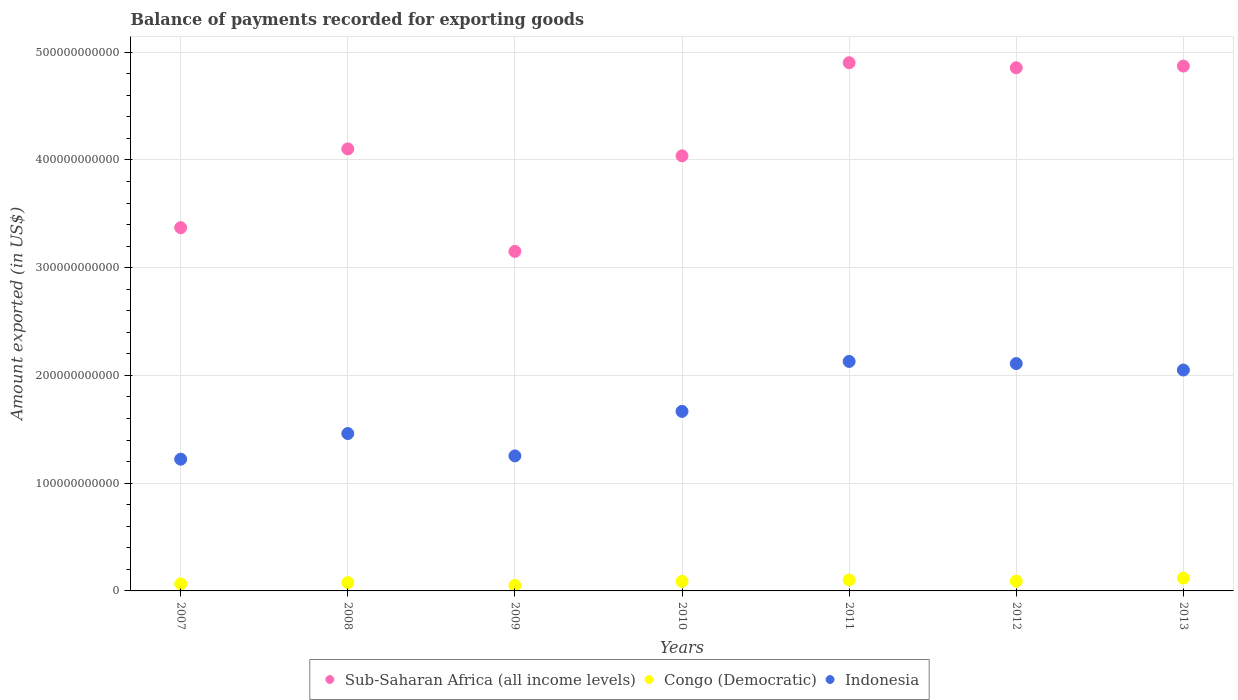How many different coloured dotlines are there?
Ensure brevity in your answer.  3. Is the number of dotlines equal to the number of legend labels?
Keep it short and to the point. Yes. What is the amount exported in Congo (Democratic) in 2011?
Give a very brief answer. 1.02e+1. Across all years, what is the maximum amount exported in Congo (Democratic)?
Your answer should be compact. 1.19e+1. Across all years, what is the minimum amount exported in Indonesia?
Keep it short and to the point. 1.22e+11. In which year was the amount exported in Congo (Democratic) maximum?
Your answer should be very brief. 2013. What is the total amount exported in Indonesia in the graph?
Keep it short and to the point. 1.19e+12. What is the difference between the amount exported in Congo (Democratic) in 2008 and that in 2010?
Offer a terse response. -1.17e+09. What is the difference between the amount exported in Congo (Democratic) in 2013 and the amount exported in Indonesia in 2010?
Offer a very short reply. -1.55e+11. What is the average amount exported in Indonesia per year?
Provide a succinct answer. 1.70e+11. In the year 2012, what is the difference between the amount exported in Congo (Democratic) and amount exported in Indonesia?
Give a very brief answer. -2.02e+11. In how many years, is the amount exported in Sub-Saharan Africa (all income levels) greater than 160000000000 US$?
Your response must be concise. 7. What is the ratio of the amount exported in Sub-Saharan Africa (all income levels) in 2007 to that in 2008?
Keep it short and to the point. 0.82. Is the amount exported in Sub-Saharan Africa (all income levels) in 2008 less than that in 2011?
Offer a terse response. Yes. Is the difference between the amount exported in Congo (Democratic) in 2008 and 2010 greater than the difference between the amount exported in Indonesia in 2008 and 2010?
Your answer should be compact. Yes. What is the difference between the highest and the second highest amount exported in Sub-Saharan Africa (all income levels)?
Ensure brevity in your answer.  3.12e+09. What is the difference between the highest and the lowest amount exported in Congo (Democratic)?
Keep it short and to the point. 6.89e+09. In how many years, is the amount exported in Indonesia greater than the average amount exported in Indonesia taken over all years?
Provide a short and direct response. 3. Is the sum of the amount exported in Indonesia in 2007 and 2012 greater than the maximum amount exported in Sub-Saharan Africa (all income levels) across all years?
Keep it short and to the point. No. Does the amount exported in Sub-Saharan Africa (all income levels) monotonically increase over the years?
Offer a very short reply. No. Is the amount exported in Congo (Democratic) strictly less than the amount exported in Indonesia over the years?
Offer a very short reply. Yes. What is the difference between two consecutive major ticks on the Y-axis?
Keep it short and to the point. 1.00e+11. Are the values on the major ticks of Y-axis written in scientific E-notation?
Offer a terse response. No. Does the graph contain grids?
Provide a succinct answer. Yes. How many legend labels are there?
Provide a short and direct response. 3. What is the title of the graph?
Make the answer very short. Balance of payments recorded for exporting goods. Does "East Asia (all income levels)" appear as one of the legend labels in the graph?
Your answer should be compact. No. What is the label or title of the X-axis?
Give a very brief answer. Years. What is the label or title of the Y-axis?
Ensure brevity in your answer.  Amount exported (in US$). What is the Amount exported (in US$) of Sub-Saharan Africa (all income levels) in 2007?
Your answer should be compact. 3.37e+11. What is the Amount exported (in US$) of Congo (Democratic) in 2007?
Provide a succinct answer. 6.54e+09. What is the Amount exported (in US$) in Indonesia in 2007?
Provide a succinct answer. 1.22e+11. What is the Amount exported (in US$) in Sub-Saharan Africa (all income levels) in 2008?
Give a very brief answer. 4.10e+11. What is the Amount exported (in US$) of Congo (Democratic) in 2008?
Give a very brief answer. 7.70e+09. What is the Amount exported (in US$) in Indonesia in 2008?
Provide a succinct answer. 1.46e+11. What is the Amount exported (in US$) of Sub-Saharan Africa (all income levels) in 2009?
Your answer should be compact. 3.15e+11. What is the Amount exported (in US$) in Congo (Democratic) in 2009?
Your response must be concise. 5.02e+09. What is the Amount exported (in US$) of Indonesia in 2009?
Provide a short and direct response. 1.25e+11. What is the Amount exported (in US$) of Sub-Saharan Africa (all income levels) in 2010?
Ensure brevity in your answer.  4.04e+11. What is the Amount exported (in US$) of Congo (Democratic) in 2010?
Ensure brevity in your answer.  8.87e+09. What is the Amount exported (in US$) in Indonesia in 2010?
Your answer should be very brief. 1.67e+11. What is the Amount exported (in US$) of Sub-Saharan Africa (all income levels) in 2011?
Keep it short and to the point. 4.90e+11. What is the Amount exported (in US$) of Congo (Democratic) in 2011?
Make the answer very short. 1.02e+1. What is the Amount exported (in US$) of Indonesia in 2011?
Offer a terse response. 2.13e+11. What is the Amount exported (in US$) of Sub-Saharan Africa (all income levels) in 2012?
Offer a terse response. 4.86e+11. What is the Amount exported (in US$) in Congo (Democratic) in 2012?
Keep it short and to the point. 9.03e+09. What is the Amount exported (in US$) in Indonesia in 2012?
Offer a terse response. 2.11e+11. What is the Amount exported (in US$) of Sub-Saharan Africa (all income levels) in 2013?
Give a very brief answer. 4.87e+11. What is the Amount exported (in US$) of Congo (Democratic) in 2013?
Your answer should be compact. 1.19e+1. What is the Amount exported (in US$) of Indonesia in 2013?
Your response must be concise. 2.05e+11. Across all years, what is the maximum Amount exported (in US$) in Sub-Saharan Africa (all income levels)?
Offer a terse response. 4.90e+11. Across all years, what is the maximum Amount exported (in US$) in Congo (Democratic)?
Your response must be concise. 1.19e+1. Across all years, what is the maximum Amount exported (in US$) of Indonesia?
Your response must be concise. 2.13e+11. Across all years, what is the minimum Amount exported (in US$) in Sub-Saharan Africa (all income levels)?
Your answer should be compact. 3.15e+11. Across all years, what is the minimum Amount exported (in US$) in Congo (Democratic)?
Your response must be concise. 5.02e+09. Across all years, what is the minimum Amount exported (in US$) of Indonesia?
Your answer should be very brief. 1.22e+11. What is the total Amount exported (in US$) of Sub-Saharan Africa (all income levels) in the graph?
Your answer should be compact. 2.93e+12. What is the total Amount exported (in US$) of Congo (Democratic) in the graph?
Your answer should be very brief. 5.93e+1. What is the total Amount exported (in US$) in Indonesia in the graph?
Make the answer very short. 1.19e+12. What is the difference between the Amount exported (in US$) of Sub-Saharan Africa (all income levels) in 2007 and that in 2008?
Keep it short and to the point. -7.31e+1. What is the difference between the Amount exported (in US$) in Congo (Democratic) in 2007 and that in 2008?
Provide a succinct answer. -1.16e+09. What is the difference between the Amount exported (in US$) in Indonesia in 2007 and that in 2008?
Give a very brief answer. -2.38e+1. What is the difference between the Amount exported (in US$) of Sub-Saharan Africa (all income levels) in 2007 and that in 2009?
Your answer should be compact. 2.20e+1. What is the difference between the Amount exported (in US$) in Congo (Democratic) in 2007 and that in 2009?
Your answer should be compact. 1.52e+09. What is the difference between the Amount exported (in US$) in Indonesia in 2007 and that in 2009?
Ensure brevity in your answer.  -3.06e+09. What is the difference between the Amount exported (in US$) in Sub-Saharan Africa (all income levels) in 2007 and that in 2010?
Provide a succinct answer. -6.67e+1. What is the difference between the Amount exported (in US$) in Congo (Democratic) in 2007 and that in 2010?
Offer a terse response. -2.33e+09. What is the difference between the Amount exported (in US$) in Indonesia in 2007 and that in 2010?
Ensure brevity in your answer.  -4.44e+1. What is the difference between the Amount exported (in US$) in Sub-Saharan Africa (all income levels) in 2007 and that in 2011?
Give a very brief answer. -1.53e+11. What is the difference between the Amount exported (in US$) of Congo (Democratic) in 2007 and that in 2011?
Offer a very short reply. -3.67e+09. What is the difference between the Amount exported (in US$) in Indonesia in 2007 and that in 2011?
Keep it short and to the point. -9.07e+1. What is the difference between the Amount exported (in US$) of Sub-Saharan Africa (all income levels) in 2007 and that in 2012?
Provide a succinct answer. -1.48e+11. What is the difference between the Amount exported (in US$) of Congo (Democratic) in 2007 and that in 2012?
Your answer should be compact. -2.49e+09. What is the difference between the Amount exported (in US$) in Indonesia in 2007 and that in 2012?
Your answer should be compact. -8.87e+1. What is the difference between the Amount exported (in US$) of Sub-Saharan Africa (all income levels) in 2007 and that in 2013?
Provide a short and direct response. -1.50e+11. What is the difference between the Amount exported (in US$) of Congo (Democratic) in 2007 and that in 2013?
Your response must be concise. -5.37e+09. What is the difference between the Amount exported (in US$) of Indonesia in 2007 and that in 2013?
Your response must be concise. -8.28e+1. What is the difference between the Amount exported (in US$) of Sub-Saharan Africa (all income levels) in 2008 and that in 2009?
Your response must be concise. 9.51e+1. What is the difference between the Amount exported (in US$) in Congo (Democratic) in 2008 and that in 2009?
Provide a short and direct response. 2.68e+09. What is the difference between the Amount exported (in US$) in Indonesia in 2008 and that in 2009?
Your response must be concise. 2.07e+1. What is the difference between the Amount exported (in US$) of Sub-Saharan Africa (all income levels) in 2008 and that in 2010?
Provide a short and direct response. 6.41e+09. What is the difference between the Amount exported (in US$) in Congo (Democratic) in 2008 and that in 2010?
Offer a terse response. -1.17e+09. What is the difference between the Amount exported (in US$) of Indonesia in 2008 and that in 2010?
Keep it short and to the point. -2.06e+1. What is the difference between the Amount exported (in US$) in Sub-Saharan Africa (all income levels) in 2008 and that in 2011?
Keep it short and to the point. -8.00e+1. What is the difference between the Amount exported (in US$) in Congo (Democratic) in 2008 and that in 2011?
Offer a terse response. -2.51e+09. What is the difference between the Amount exported (in US$) of Indonesia in 2008 and that in 2011?
Your answer should be compact. -6.69e+1. What is the difference between the Amount exported (in US$) in Sub-Saharan Africa (all income levels) in 2008 and that in 2012?
Give a very brief answer. -7.53e+1. What is the difference between the Amount exported (in US$) of Congo (Democratic) in 2008 and that in 2012?
Your answer should be very brief. -1.33e+09. What is the difference between the Amount exported (in US$) of Indonesia in 2008 and that in 2012?
Give a very brief answer. -6.50e+1. What is the difference between the Amount exported (in US$) in Sub-Saharan Africa (all income levels) in 2008 and that in 2013?
Keep it short and to the point. -7.69e+1. What is the difference between the Amount exported (in US$) of Congo (Democratic) in 2008 and that in 2013?
Ensure brevity in your answer.  -4.21e+09. What is the difference between the Amount exported (in US$) in Indonesia in 2008 and that in 2013?
Your response must be concise. -5.90e+1. What is the difference between the Amount exported (in US$) of Sub-Saharan Africa (all income levels) in 2009 and that in 2010?
Provide a succinct answer. -8.87e+1. What is the difference between the Amount exported (in US$) in Congo (Democratic) in 2009 and that in 2010?
Provide a short and direct response. -3.85e+09. What is the difference between the Amount exported (in US$) of Indonesia in 2009 and that in 2010?
Your answer should be very brief. -4.13e+1. What is the difference between the Amount exported (in US$) of Sub-Saharan Africa (all income levels) in 2009 and that in 2011?
Provide a short and direct response. -1.75e+11. What is the difference between the Amount exported (in US$) in Congo (Democratic) in 2009 and that in 2011?
Ensure brevity in your answer.  -5.19e+09. What is the difference between the Amount exported (in US$) of Indonesia in 2009 and that in 2011?
Your answer should be compact. -8.77e+1. What is the difference between the Amount exported (in US$) in Sub-Saharan Africa (all income levels) in 2009 and that in 2012?
Provide a succinct answer. -1.70e+11. What is the difference between the Amount exported (in US$) in Congo (Democratic) in 2009 and that in 2012?
Your response must be concise. -4.01e+09. What is the difference between the Amount exported (in US$) of Indonesia in 2009 and that in 2012?
Your answer should be very brief. -8.57e+1. What is the difference between the Amount exported (in US$) of Sub-Saharan Africa (all income levels) in 2009 and that in 2013?
Your response must be concise. -1.72e+11. What is the difference between the Amount exported (in US$) of Congo (Democratic) in 2009 and that in 2013?
Your answer should be very brief. -6.89e+09. What is the difference between the Amount exported (in US$) of Indonesia in 2009 and that in 2013?
Offer a very short reply. -7.97e+1. What is the difference between the Amount exported (in US$) of Sub-Saharan Africa (all income levels) in 2010 and that in 2011?
Give a very brief answer. -8.64e+1. What is the difference between the Amount exported (in US$) of Congo (Democratic) in 2010 and that in 2011?
Provide a succinct answer. -1.34e+09. What is the difference between the Amount exported (in US$) in Indonesia in 2010 and that in 2011?
Your response must be concise. -4.64e+1. What is the difference between the Amount exported (in US$) of Sub-Saharan Africa (all income levels) in 2010 and that in 2012?
Provide a short and direct response. -8.17e+1. What is the difference between the Amount exported (in US$) of Congo (Democratic) in 2010 and that in 2012?
Your answer should be compact. -1.65e+08. What is the difference between the Amount exported (in US$) of Indonesia in 2010 and that in 2012?
Provide a short and direct response. -4.44e+1. What is the difference between the Amount exported (in US$) in Sub-Saharan Africa (all income levels) in 2010 and that in 2013?
Make the answer very short. -8.33e+1. What is the difference between the Amount exported (in US$) of Congo (Democratic) in 2010 and that in 2013?
Offer a terse response. -3.04e+09. What is the difference between the Amount exported (in US$) of Indonesia in 2010 and that in 2013?
Make the answer very short. -3.84e+1. What is the difference between the Amount exported (in US$) in Sub-Saharan Africa (all income levels) in 2011 and that in 2012?
Your response must be concise. 4.70e+09. What is the difference between the Amount exported (in US$) of Congo (Democratic) in 2011 and that in 2012?
Give a very brief answer. 1.18e+09. What is the difference between the Amount exported (in US$) of Indonesia in 2011 and that in 2012?
Give a very brief answer. 1.99e+09. What is the difference between the Amount exported (in US$) in Sub-Saharan Africa (all income levels) in 2011 and that in 2013?
Provide a short and direct response. 3.12e+09. What is the difference between the Amount exported (in US$) of Congo (Democratic) in 2011 and that in 2013?
Your response must be concise. -1.70e+09. What is the difference between the Amount exported (in US$) of Indonesia in 2011 and that in 2013?
Your answer should be compact. 7.96e+09. What is the difference between the Amount exported (in US$) in Sub-Saharan Africa (all income levels) in 2012 and that in 2013?
Make the answer very short. -1.57e+09. What is the difference between the Amount exported (in US$) of Congo (Democratic) in 2012 and that in 2013?
Your answer should be compact. -2.88e+09. What is the difference between the Amount exported (in US$) of Indonesia in 2012 and that in 2013?
Provide a short and direct response. 5.97e+09. What is the difference between the Amount exported (in US$) of Sub-Saharan Africa (all income levels) in 2007 and the Amount exported (in US$) of Congo (Democratic) in 2008?
Your answer should be compact. 3.29e+11. What is the difference between the Amount exported (in US$) in Sub-Saharan Africa (all income levels) in 2007 and the Amount exported (in US$) in Indonesia in 2008?
Offer a terse response. 1.91e+11. What is the difference between the Amount exported (in US$) in Congo (Democratic) in 2007 and the Amount exported (in US$) in Indonesia in 2008?
Your response must be concise. -1.40e+11. What is the difference between the Amount exported (in US$) of Sub-Saharan Africa (all income levels) in 2007 and the Amount exported (in US$) of Congo (Democratic) in 2009?
Give a very brief answer. 3.32e+11. What is the difference between the Amount exported (in US$) in Sub-Saharan Africa (all income levels) in 2007 and the Amount exported (in US$) in Indonesia in 2009?
Your response must be concise. 2.12e+11. What is the difference between the Amount exported (in US$) in Congo (Democratic) in 2007 and the Amount exported (in US$) in Indonesia in 2009?
Your answer should be very brief. -1.19e+11. What is the difference between the Amount exported (in US$) in Sub-Saharan Africa (all income levels) in 2007 and the Amount exported (in US$) in Congo (Democratic) in 2010?
Keep it short and to the point. 3.28e+11. What is the difference between the Amount exported (in US$) in Sub-Saharan Africa (all income levels) in 2007 and the Amount exported (in US$) in Indonesia in 2010?
Offer a very short reply. 1.71e+11. What is the difference between the Amount exported (in US$) in Congo (Democratic) in 2007 and the Amount exported (in US$) in Indonesia in 2010?
Your answer should be compact. -1.60e+11. What is the difference between the Amount exported (in US$) of Sub-Saharan Africa (all income levels) in 2007 and the Amount exported (in US$) of Congo (Democratic) in 2011?
Keep it short and to the point. 3.27e+11. What is the difference between the Amount exported (in US$) in Sub-Saharan Africa (all income levels) in 2007 and the Amount exported (in US$) in Indonesia in 2011?
Your answer should be very brief. 1.24e+11. What is the difference between the Amount exported (in US$) in Congo (Democratic) in 2007 and the Amount exported (in US$) in Indonesia in 2011?
Offer a terse response. -2.06e+11. What is the difference between the Amount exported (in US$) of Sub-Saharan Africa (all income levels) in 2007 and the Amount exported (in US$) of Congo (Democratic) in 2012?
Provide a succinct answer. 3.28e+11. What is the difference between the Amount exported (in US$) of Sub-Saharan Africa (all income levels) in 2007 and the Amount exported (in US$) of Indonesia in 2012?
Provide a succinct answer. 1.26e+11. What is the difference between the Amount exported (in US$) of Congo (Democratic) in 2007 and the Amount exported (in US$) of Indonesia in 2012?
Your response must be concise. -2.04e+11. What is the difference between the Amount exported (in US$) of Sub-Saharan Africa (all income levels) in 2007 and the Amount exported (in US$) of Congo (Democratic) in 2013?
Provide a short and direct response. 3.25e+11. What is the difference between the Amount exported (in US$) in Sub-Saharan Africa (all income levels) in 2007 and the Amount exported (in US$) in Indonesia in 2013?
Make the answer very short. 1.32e+11. What is the difference between the Amount exported (in US$) of Congo (Democratic) in 2007 and the Amount exported (in US$) of Indonesia in 2013?
Provide a succinct answer. -1.98e+11. What is the difference between the Amount exported (in US$) of Sub-Saharan Africa (all income levels) in 2008 and the Amount exported (in US$) of Congo (Democratic) in 2009?
Your answer should be compact. 4.05e+11. What is the difference between the Amount exported (in US$) in Sub-Saharan Africa (all income levels) in 2008 and the Amount exported (in US$) in Indonesia in 2009?
Keep it short and to the point. 2.85e+11. What is the difference between the Amount exported (in US$) in Congo (Democratic) in 2008 and the Amount exported (in US$) in Indonesia in 2009?
Your answer should be compact. -1.18e+11. What is the difference between the Amount exported (in US$) in Sub-Saharan Africa (all income levels) in 2008 and the Amount exported (in US$) in Congo (Democratic) in 2010?
Your answer should be very brief. 4.01e+11. What is the difference between the Amount exported (in US$) in Sub-Saharan Africa (all income levels) in 2008 and the Amount exported (in US$) in Indonesia in 2010?
Provide a succinct answer. 2.44e+11. What is the difference between the Amount exported (in US$) of Congo (Democratic) in 2008 and the Amount exported (in US$) of Indonesia in 2010?
Provide a succinct answer. -1.59e+11. What is the difference between the Amount exported (in US$) of Sub-Saharan Africa (all income levels) in 2008 and the Amount exported (in US$) of Congo (Democratic) in 2011?
Offer a terse response. 4.00e+11. What is the difference between the Amount exported (in US$) of Sub-Saharan Africa (all income levels) in 2008 and the Amount exported (in US$) of Indonesia in 2011?
Ensure brevity in your answer.  1.97e+11. What is the difference between the Amount exported (in US$) in Congo (Democratic) in 2008 and the Amount exported (in US$) in Indonesia in 2011?
Your response must be concise. -2.05e+11. What is the difference between the Amount exported (in US$) of Sub-Saharan Africa (all income levels) in 2008 and the Amount exported (in US$) of Congo (Democratic) in 2012?
Provide a succinct answer. 4.01e+11. What is the difference between the Amount exported (in US$) of Sub-Saharan Africa (all income levels) in 2008 and the Amount exported (in US$) of Indonesia in 2012?
Provide a short and direct response. 1.99e+11. What is the difference between the Amount exported (in US$) of Congo (Democratic) in 2008 and the Amount exported (in US$) of Indonesia in 2012?
Provide a succinct answer. -2.03e+11. What is the difference between the Amount exported (in US$) of Sub-Saharan Africa (all income levels) in 2008 and the Amount exported (in US$) of Congo (Democratic) in 2013?
Give a very brief answer. 3.98e+11. What is the difference between the Amount exported (in US$) in Sub-Saharan Africa (all income levels) in 2008 and the Amount exported (in US$) in Indonesia in 2013?
Your answer should be very brief. 2.05e+11. What is the difference between the Amount exported (in US$) of Congo (Democratic) in 2008 and the Amount exported (in US$) of Indonesia in 2013?
Make the answer very short. -1.97e+11. What is the difference between the Amount exported (in US$) in Sub-Saharan Africa (all income levels) in 2009 and the Amount exported (in US$) in Congo (Democratic) in 2010?
Provide a succinct answer. 3.06e+11. What is the difference between the Amount exported (in US$) in Sub-Saharan Africa (all income levels) in 2009 and the Amount exported (in US$) in Indonesia in 2010?
Give a very brief answer. 1.48e+11. What is the difference between the Amount exported (in US$) of Congo (Democratic) in 2009 and the Amount exported (in US$) of Indonesia in 2010?
Provide a short and direct response. -1.62e+11. What is the difference between the Amount exported (in US$) of Sub-Saharan Africa (all income levels) in 2009 and the Amount exported (in US$) of Congo (Democratic) in 2011?
Provide a short and direct response. 3.05e+11. What is the difference between the Amount exported (in US$) of Sub-Saharan Africa (all income levels) in 2009 and the Amount exported (in US$) of Indonesia in 2011?
Make the answer very short. 1.02e+11. What is the difference between the Amount exported (in US$) in Congo (Democratic) in 2009 and the Amount exported (in US$) in Indonesia in 2011?
Your response must be concise. -2.08e+11. What is the difference between the Amount exported (in US$) in Sub-Saharan Africa (all income levels) in 2009 and the Amount exported (in US$) in Congo (Democratic) in 2012?
Give a very brief answer. 3.06e+11. What is the difference between the Amount exported (in US$) of Sub-Saharan Africa (all income levels) in 2009 and the Amount exported (in US$) of Indonesia in 2012?
Keep it short and to the point. 1.04e+11. What is the difference between the Amount exported (in US$) in Congo (Democratic) in 2009 and the Amount exported (in US$) in Indonesia in 2012?
Provide a succinct answer. -2.06e+11. What is the difference between the Amount exported (in US$) in Sub-Saharan Africa (all income levels) in 2009 and the Amount exported (in US$) in Congo (Democratic) in 2013?
Keep it short and to the point. 3.03e+11. What is the difference between the Amount exported (in US$) in Sub-Saharan Africa (all income levels) in 2009 and the Amount exported (in US$) in Indonesia in 2013?
Offer a terse response. 1.10e+11. What is the difference between the Amount exported (in US$) of Congo (Democratic) in 2009 and the Amount exported (in US$) of Indonesia in 2013?
Your answer should be very brief. -2.00e+11. What is the difference between the Amount exported (in US$) in Sub-Saharan Africa (all income levels) in 2010 and the Amount exported (in US$) in Congo (Democratic) in 2011?
Offer a very short reply. 3.94e+11. What is the difference between the Amount exported (in US$) of Sub-Saharan Africa (all income levels) in 2010 and the Amount exported (in US$) of Indonesia in 2011?
Offer a terse response. 1.91e+11. What is the difference between the Amount exported (in US$) of Congo (Democratic) in 2010 and the Amount exported (in US$) of Indonesia in 2011?
Provide a succinct answer. -2.04e+11. What is the difference between the Amount exported (in US$) in Sub-Saharan Africa (all income levels) in 2010 and the Amount exported (in US$) in Congo (Democratic) in 2012?
Keep it short and to the point. 3.95e+11. What is the difference between the Amount exported (in US$) in Sub-Saharan Africa (all income levels) in 2010 and the Amount exported (in US$) in Indonesia in 2012?
Give a very brief answer. 1.93e+11. What is the difference between the Amount exported (in US$) of Congo (Democratic) in 2010 and the Amount exported (in US$) of Indonesia in 2012?
Your answer should be very brief. -2.02e+11. What is the difference between the Amount exported (in US$) of Sub-Saharan Africa (all income levels) in 2010 and the Amount exported (in US$) of Congo (Democratic) in 2013?
Provide a short and direct response. 3.92e+11. What is the difference between the Amount exported (in US$) in Sub-Saharan Africa (all income levels) in 2010 and the Amount exported (in US$) in Indonesia in 2013?
Provide a short and direct response. 1.99e+11. What is the difference between the Amount exported (in US$) in Congo (Democratic) in 2010 and the Amount exported (in US$) in Indonesia in 2013?
Ensure brevity in your answer.  -1.96e+11. What is the difference between the Amount exported (in US$) of Sub-Saharan Africa (all income levels) in 2011 and the Amount exported (in US$) of Congo (Democratic) in 2012?
Provide a short and direct response. 4.81e+11. What is the difference between the Amount exported (in US$) of Sub-Saharan Africa (all income levels) in 2011 and the Amount exported (in US$) of Indonesia in 2012?
Keep it short and to the point. 2.79e+11. What is the difference between the Amount exported (in US$) of Congo (Democratic) in 2011 and the Amount exported (in US$) of Indonesia in 2012?
Provide a short and direct response. -2.01e+11. What is the difference between the Amount exported (in US$) in Sub-Saharan Africa (all income levels) in 2011 and the Amount exported (in US$) in Congo (Democratic) in 2013?
Offer a terse response. 4.78e+11. What is the difference between the Amount exported (in US$) of Sub-Saharan Africa (all income levels) in 2011 and the Amount exported (in US$) of Indonesia in 2013?
Provide a short and direct response. 2.85e+11. What is the difference between the Amount exported (in US$) of Congo (Democratic) in 2011 and the Amount exported (in US$) of Indonesia in 2013?
Your response must be concise. -1.95e+11. What is the difference between the Amount exported (in US$) in Sub-Saharan Africa (all income levels) in 2012 and the Amount exported (in US$) in Congo (Democratic) in 2013?
Make the answer very short. 4.74e+11. What is the difference between the Amount exported (in US$) of Sub-Saharan Africa (all income levels) in 2012 and the Amount exported (in US$) of Indonesia in 2013?
Give a very brief answer. 2.81e+11. What is the difference between the Amount exported (in US$) of Congo (Democratic) in 2012 and the Amount exported (in US$) of Indonesia in 2013?
Provide a succinct answer. -1.96e+11. What is the average Amount exported (in US$) of Sub-Saharan Africa (all income levels) per year?
Ensure brevity in your answer.  4.18e+11. What is the average Amount exported (in US$) of Congo (Democratic) per year?
Ensure brevity in your answer.  8.47e+09. What is the average Amount exported (in US$) in Indonesia per year?
Your answer should be very brief. 1.70e+11. In the year 2007, what is the difference between the Amount exported (in US$) in Sub-Saharan Africa (all income levels) and Amount exported (in US$) in Congo (Democratic)?
Make the answer very short. 3.31e+11. In the year 2007, what is the difference between the Amount exported (in US$) in Sub-Saharan Africa (all income levels) and Amount exported (in US$) in Indonesia?
Provide a short and direct response. 2.15e+11. In the year 2007, what is the difference between the Amount exported (in US$) of Congo (Democratic) and Amount exported (in US$) of Indonesia?
Your answer should be very brief. -1.16e+11. In the year 2008, what is the difference between the Amount exported (in US$) of Sub-Saharan Africa (all income levels) and Amount exported (in US$) of Congo (Democratic)?
Your answer should be compact. 4.03e+11. In the year 2008, what is the difference between the Amount exported (in US$) in Sub-Saharan Africa (all income levels) and Amount exported (in US$) in Indonesia?
Make the answer very short. 2.64e+11. In the year 2008, what is the difference between the Amount exported (in US$) in Congo (Democratic) and Amount exported (in US$) in Indonesia?
Ensure brevity in your answer.  -1.38e+11. In the year 2009, what is the difference between the Amount exported (in US$) in Sub-Saharan Africa (all income levels) and Amount exported (in US$) in Congo (Democratic)?
Offer a terse response. 3.10e+11. In the year 2009, what is the difference between the Amount exported (in US$) of Sub-Saharan Africa (all income levels) and Amount exported (in US$) of Indonesia?
Your response must be concise. 1.90e+11. In the year 2009, what is the difference between the Amount exported (in US$) in Congo (Democratic) and Amount exported (in US$) in Indonesia?
Keep it short and to the point. -1.20e+11. In the year 2010, what is the difference between the Amount exported (in US$) of Sub-Saharan Africa (all income levels) and Amount exported (in US$) of Congo (Democratic)?
Your response must be concise. 3.95e+11. In the year 2010, what is the difference between the Amount exported (in US$) in Sub-Saharan Africa (all income levels) and Amount exported (in US$) in Indonesia?
Ensure brevity in your answer.  2.37e+11. In the year 2010, what is the difference between the Amount exported (in US$) of Congo (Democratic) and Amount exported (in US$) of Indonesia?
Your response must be concise. -1.58e+11. In the year 2011, what is the difference between the Amount exported (in US$) of Sub-Saharan Africa (all income levels) and Amount exported (in US$) of Congo (Democratic)?
Keep it short and to the point. 4.80e+11. In the year 2011, what is the difference between the Amount exported (in US$) of Sub-Saharan Africa (all income levels) and Amount exported (in US$) of Indonesia?
Give a very brief answer. 2.77e+11. In the year 2011, what is the difference between the Amount exported (in US$) in Congo (Democratic) and Amount exported (in US$) in Indonesia?
Your answer should be very brief. -2.03e+11. In the year 2012, what is the difference between the Amount exported (in US$) of Sub-Saharan Africa (all income levels) and Amount exported (in US$) of Congo (Democratic)?
Keep it short and to the point. 4.77e+11. In the year 2012, what is the difference between the Amount exported (in US$) of Sub-Saharan Africa (all income levels) and Amount exported (in US$) of Indonesia?
Your answer should be very brief. 2.75e+11. In the year 2012, what is the difference between the Amount exported (in US$) in Congo (Democratic) and Amount exported (in US$) in Indonesia?
Provide a short and direct response. -2.02e+11. In the year 2013, what is the difference between the Amount exported (in US$) of Sub-Saharan Africa (all income levels) and Amount exported (in US$) of Congo (Democratic)?
Ensure brevity in your answer.  4.75e+11. In the year 2013, what is the difference between the Amount exported (in US$) of Sub-Saharan Africa (all income levels) and Amount exported (in US$) of Indonesia?
Make the answer very short. 2.82e+11. In the year 2013, what is the difference between the Amount exported (in US$) of Congo (Democratic) and Amount exported (in US$) of Indonesia?
Offer a very short reply. -1.93e+11. What is the ratio of the Amount exported (in US$) of Sub-Saharan Africa (all income levels) in 2007 to that in 2008?
Offer a very short reply. 0.82. What is the ratio of the Amount exported (in US$) in Congo (Democratic) in 2007 to that in 2008?
Offer a terse response. 0.85. What is the ratio of the Amount exported (in US$) in Indonesia in 2007 to that in 2008?
Provide a succinct answer. 0.84. What is the ratio of the Amount exported (in US$) in Sub-Saharan Africa (all income levels) in 2007 to that in 2009?
Ensure brevity in your answer.  1.07. What is the ratio of the Amount exported (in US$) in Congo (Democratic) in 2007 to that in 2009?
Your answer should be compact. 1.3. What is the ratio of the Amount exported (in US$) of Indonesia in 2007 to that in 2009?
Your answer should be very brief. 0.98. What is the ratio of the Amount exported (in US$) of Sub-Saharan Africa (all income levels) in 2007 to that in 2010?
Provide a short and direct response. 0.83. What is the ratio of the Amount exported (in US$) of Congo (Democratic) in 2007 to that in 2010?
Offer a terse response. 0.74. What is the ratio of the Amount exported (in US$) in Indonesia in 2007 to that in 2010?
Your answer should be very brief. 0.73. What is the ratio of the Amount exported (in US$) of Sub-Saharan Africa (all income levels) in 2007 to that in 2011?
Offer a terse response. 0.69. What is the ratio of the Amount exported (in US$) in Congo (Democratic) in 2007 to that in 2011?
Your response must be concise. 0.64. What is the ratio of the Amount exported (in US$) in Indonesia in 2007 to that in 2011?
Your response must be concise. 0.57. What is the ratio of the Amount exported (in US$) in Sub-Saharan Africa (all income levels) in 2007 to that in 2012?
Make the answer very short. 0.69. What is the ratio of the Amount exported (in US$) of Congo (Democratic) in 2007 to that in 2012?
Your response must be concise. 0.72. What is the ratio of the Amount exported (in US$) of Indonesia in 2007 to that in 2012?
Keep it short and to the point. 0.58. What is the ratio of the Amount exported (in US$) of Sub-Saharan Africa (all income levels) in 2007 to that in 2013?
Provide a succinct answer. 0.69. What is the ratio of the Amount exported (in US$) in Congo (Democratic) in 2007 to that in 2013?
Give a very brief answer. 0.55. What is the ratio of the Amount exported (in US$) of Indonesia in 2007 to that in 2013?
Make the answer very short. 0.6. What is the ratio of the Amount exported (in US$) in Sub-Saharan Africa (all income levels) in 2008 to that in 2009?
Provide a succinct answer. 1.3. What is the ratio of the Amount exported (in US$) in Congo (Democratic) in 2008 to that in 2009?
Offer a very short reply. 1.53. What is the ratio of the Amount exported (in US$) in Indonesia in 2008 to that in 2009?
Provide a short and direct response. 1.17. What is the ratio of the Amount exported (in US$) in Sub-Saharan Africa (all income levels) in 2008 to that in 2010?
Provide a short and direct response. 1.02. What is the ratio of the Amount exported (in US$) of Congo (Democratic) in 2008 to that in 2010?
Offer a very short reply. 0.87. What is the ratio of the Amount exported (in US$) in Indonesia in 2008 to that in 2010?
Your answer should be very brief. 0.88. What is the ratio of the Amount exported (in US$) in Sub-Saharan Africa (all income levels) in 2008 to that in 2011?
Ensure brevity in your answer.  0.84. What is the ratio of the Amount exported (in US$) of Congo (Democratic) in 2008 to that in 2011?
Provide a succinct answer. 0.75. What is the ratio of the Amount exported (in US$) of Indonesia in 2008 to that in 2011?
Your response must be concise. 0.69. What is the ratio of the Amount exported (in US$) of Sub-Saharan Africa (all income levels) in 2008 to that in 2012?
Your response must be concise. 0.84. What is the ratio of the Amount exported (in US$) in Congo (Democratic) in 2008 to that in 2012?
Your response must be concise. 0.85. What is the ratio of the Amount exported (in US$) of Indonesia in 2008 to that in 2012?
Your response must be concise. 0.69. What is the ratio of the Amount exported (in US$) in Sub-Saharan Africa (all income levels) in 2008 to that in 2013?
Keep it short and to the point. 0.84. What is the ratio of the Amount exported (in US$) in Congo (Democratic) in 2008 to that in 2013?
Your answer should be very brief. 0.65. What is the ratio of the Amount exported (in US$) in Indonesia in 2008 to that in 2013?
Ensure brevity in your answer.  0.71. What is the ratio of the Amount exported (in US$) of Sub-Saharan Africa (all income levels) in 2009 to that in 2010?
Provide a short and direct response. 0.78. What is the ratio of the Amount exported (in US$) in Congo (Democratic) in 2009 to that in 2010?
Provide a succinct answer. 0.57. What is the ratio of the Amount exported (in US$) of Indonesia in 2009 to that in 2010?
Keep it short and to the point. 0.75. What is the ratio of the Amount exported (in US$) of Sub-Saharan Africa (all income levels) in 2009 to that in 2011?
Offer a terse response. 0.64. What is the ratio of the Amount exported (in US$) in Congo (Democratic) in 2009 to that in 2011?
Give a very brief answer. 0.49. What is the ratio of the Amount exported (in US$) in Indonesia in 2009 to that in 2011?
Provide a succinct answer. 0.59. What is the ratio of the Amount exported (in US$) of Sub-Saharan Africa (all income levels) in 2009 to that in 2012?
Offer a very short reply. 0.65. What is the ratio of the Amount exported (in US$) of Congo (Democratic) in 2009 to that in 2012?
Make the answer very short. 0.56. What is the ratio of the Amount exported (in US$) in Indonesia in 2009 to that in 2012?
Offer a very short reply. 0.59. What is the ratio of the Amount exported (in US$) in Sub-Saharan Africa (all income levels) in 2009 to that in 2013?
Give a very brief answer. 0.65. What is the ratio of the Amount exported (in US$) in Congo (Democratic) in 2009 to that in 2013?
Your response must be concise. 0.42. What is the ratio of the Amount exported (in US$) of Indonesia in 2009 to that in 2013?
Provide a succinct answer. 0.61. What is the ratio of the Amount exported (in US$) in Sub-Saharan Africa (all income levels) in 2010 to that in 2011?
Offer a very short reply. 0.82. What is the ratio of the Amount exported (in US$) in Congo (Democratic) in 2010 to that in 2011?
Keep it short and to the point. 0.87. What is the ratio of the Amount exported (in US$) of Indonesia in 2010 to that in 2011?
Offer a terse response. 0.78. What is the ratio of the Amount exported (in US$) in Sub-Saharan Africa (all income levels) in 2010 to that in 2012?
Ensure brevity in your answer.  0.83. What is the ratio of the Amount exported (in US$) of Congo (Democratic) in 2010 to that in 2012?
Offer a terse response. 0.98. What is the ratio of the Amount exported (in US$) in Indonesia in 2010 to that in 2012?
Your answer should be very brief. 0.79. What is the ratio of the Amount exported (in US$) of Sub-Saharan Africa (all income levels) in 2010 to that in 2013?
Your response must be concise. 0.83. What is the ratio of the Amount exported (in US$) in Congo (Democratic) in 2010 to that in 2013?
Give a very brief answer. 0.74. What is the ratio of the Amount exported (in US$) in Indonesia in 2010 to that in 2013?
Offer a very short reply. 0.81. What is the ratio of the Amount exported (in US$) of Sub-Saharan Africa (all income levels) in 2011 to that in 2012?
Provide a succinct answer. 1.01. What is the ratio of the Amount exported (in US$) in Congo (Democratic) in 2011 to that in 2012?
Make the answer very short. 1.13. What is the ratio of the Amount exported (in US$) of Indonesia in 2011 to that in 2012?
Offer a very short reply. 1.01. What is the ratio of the Amount exported (in US$) in Sub-Saharan Africa (all income levels) in 2011 to that in 2013?
Provide a short and direct response. 1.01. What is the ratio of the Amount exported (in US$) of Congo (Democratic) in 2011 to that in 2013?
Make the answer very short. 0.86. What is the ratio of the Amount exported (in US$) in Indonesia in 2011 to that in 2013?
Offer a terse response. 1.04. What is the ratio of the Amount exported (in US$) of Congo (Democratic) in 2012 to that in 2013?
Make the answer very short. 0.76. What is the ratio of the Amount exported (in US$) in Indonesia in 2012 to that in 2013?
Keep it short and to the point. 1.03. What is the difference between the highest and the second highest Amount exported (in US$) in Sub-Saharan Africa (all income levels)?
Make the answer very short. 3.12e+09. What is the difference between the highest and the second highest Amount exported (in US$) of Congo (Democratic)?
Give a very brief answer. 1.70e+09. What is the difference between the highest and the second highest Amount exported (in US$) of Indonesia?
Give a very brief answer. 1.99e+09. What is the difference between the highest and the lowest Amount exported (in US$) of Sub-Saharan Africa (all income levels)?
Your answer should be very brief. 1.75e+11. What is the difference between the highest and the lowest Amount exported (in US$) of Congo (Democratic)?
Keep it short and to the point. 6.89e+09. What is the difference between the highest and the lowest Amount exported (in US$) of Indonesia?
Give a very brief answer. 9.07e+1. 